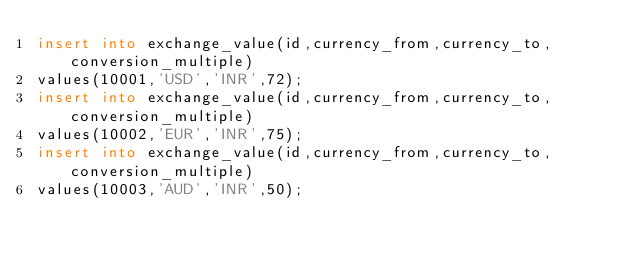Convert code to text. <code><loc_0><loc_0><loc_500><loc_500><_SQL_>insert into exchange_value(id,currency_from,currency_to,conversion_multiple)
values(10001,'USD','INR',72);
insert into exchange_value(id,currency_from,currency_to,conversion_multiple)
values(10002,'EUR','INR',75);
insert into exchange_value(id,currency_from,currency_to,conversion_multiple)
values(10003,'AUD','INR',50);</code> 